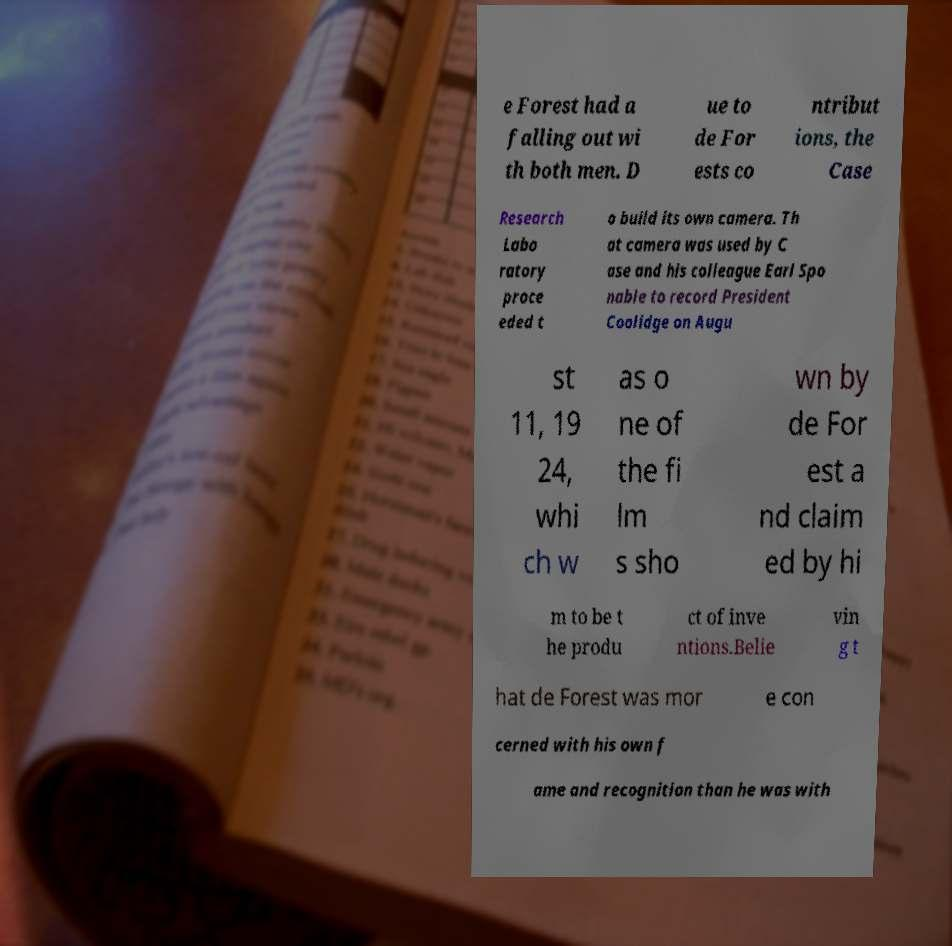Please identify and transcribe the text found in this image. e Forest had a falling out wi th both men. D ue to de For ests co ntribut ions, the Case Research Labo ratory proce eded t o build its own camera. Th at camera was used by C ase and his colleague Earl Spo nable to record President Coolidge on Augu st 11, 19 24, whi ch w as o ne of the fi lm s sho wn by de For est a nd claim ed by hi m to be t he produ ct of inve ntions.Belie vin g t hat de Forest was mor e con cerned with his own f ame and recognition than he was with 